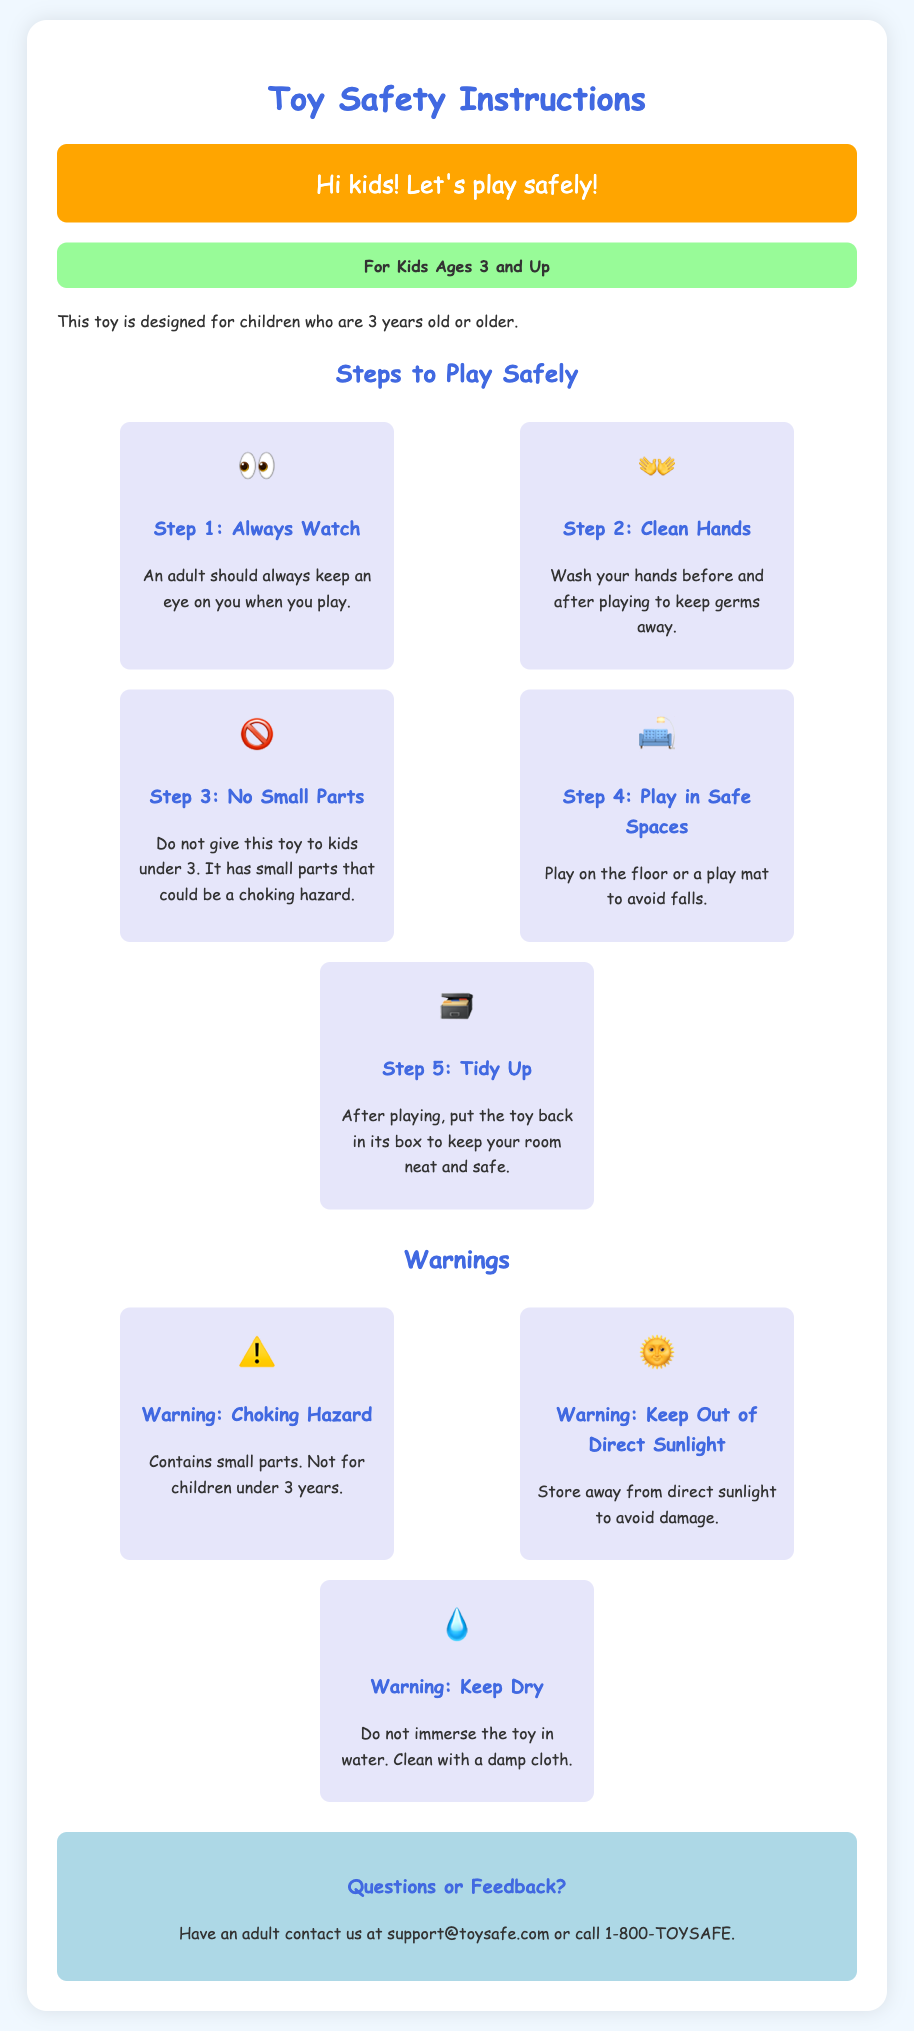What is the age restriction for this toy? The document states that this toy is designed for children who are 3 years old or older.
Answer: 3 years old What should you do before and after playing? The steps in the document emphasize the importance of washing hands before and after playing to keep germs away.
Answer: Wash your hands What are the small parts a hazard for? The document indicates that small parts could be a choking hazard, especially for younger children.
Answer: Choking hazard Where is it recommended to play with the toy? According to the instructions, it is best to play on the floor or a play mat to avoid falls.
Answer: Floor or play mat What should you do if you have questions or feedback? The document suggests that an adult should contact customer support via email or phone for any inquiries.
Answer: Contact support What is one way to keep the toy safe from damage? The warning advises to store the toy away from direct sunlight to avoid damage.
Answer: Keep out of direct sunlight What type of toy cleaning is advised? The document specifies to clean the toy with a damp cloth, indicating not to immerse it in water.
Answer: Damp cloth Who should supervise children while playing? The instructions clearly state that an adult should always watch children when they play.
Answer: An adult What should you do after playing with the toy? The document advises to put the toy back in its box to keep the room neat and safe after playing.
Answer: Put the toy back in its box 